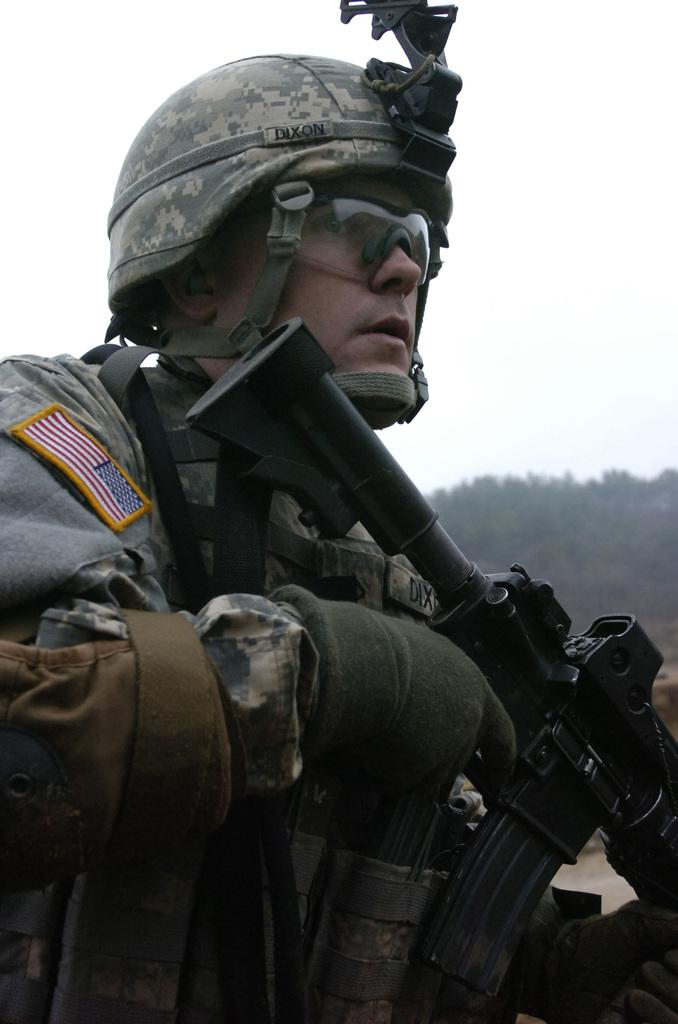What is the main subject of the image? There is a man in the image. What is the man holding in his hands? The man is holding a gun in his hands. What protective gear is the man wearing? The man is wearing goggles and a helmet. What can be seen in the background of the image? There are trees behind the man, and the sky is visible. What type of sidewalk can be seen in the image? There is no sidewalk present in the image; it features a man holding a gun, wearing goggles and a helmet, with trees and the sky visible in the background. 